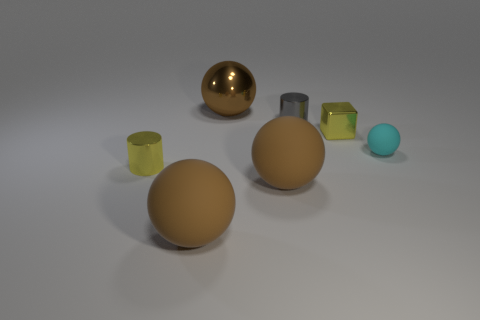Is there any other thing that is the same color as the big shiny ball?
Offer a terse response. Yes. Do the tiny yellow shiny object to the left of the tiny cube and the tiny gray shiny thing have the same shape?
Offer a terse response. Yes. How many things are tiny metallic blocks or gray cylinders?
Your answer should be very brief. 2. Is the large brown object that is left of the large brown shiny object made of the same material as the block?
Make the answer very short. No. What size is the cyan object?
Ensure brevity in your answer.  Small. What shape is the tiny metal thing that is the same color as the shiny block?
Keep it short and to the point. Cylinder. What number of blocks are large brown metallic objects or small things?
Ensure brevity in your answer.  1. Are there the same number of matte things to the left of the small gray shiny cylinder and yellow shiny things that are on the right side of the yellow shiny cylinder?
Give a very brief answer. No. There is a cyan rubber object that is the same shape as the big brown metal object; what is its size?
Your response must be concise. Small. What size is the sphere that is both behind the yellow cylinder and on the right side of the metallic ball?
Offer a terse response. Small. 